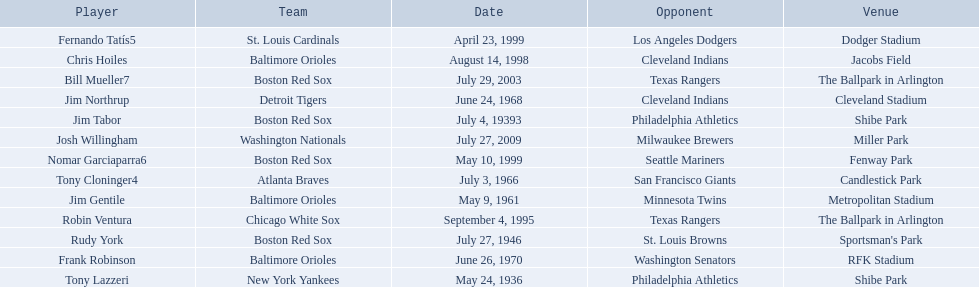Who are all the opponents? Philadelphia Athletics, Philadelphia Athletics, St. Louis Browns, Minnesota Twins, San Francisco Giants, Cleveland Indians, Washington Senators, Texas Rangers, Cleveland Indians, Los Angeles Dodgers, Seattle Mariners, Texas Rangers, Milwaukee Brewers. What teams played on july 27, 1946? Boston Red Sox, July 27, 1946, St. Louis Browns. Who was the opponent in this game? St. Louis Browns. 